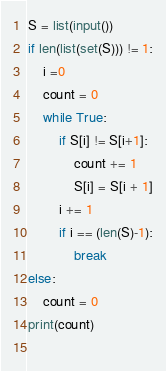Convert code to text. <code><loc_0><loc_0><loc_500><loc_500><_Python_>S = list(input())
if len(list(set(S))) != 1:
    i =0
    count = 0
    while True:
        if S[i] != S[i+1]:
            count += 1
            S[i] = S[i + 1]
        i += 1
        if i == (len(S)-1):
            break
else:
    count = 0
print(count)
            </code> 